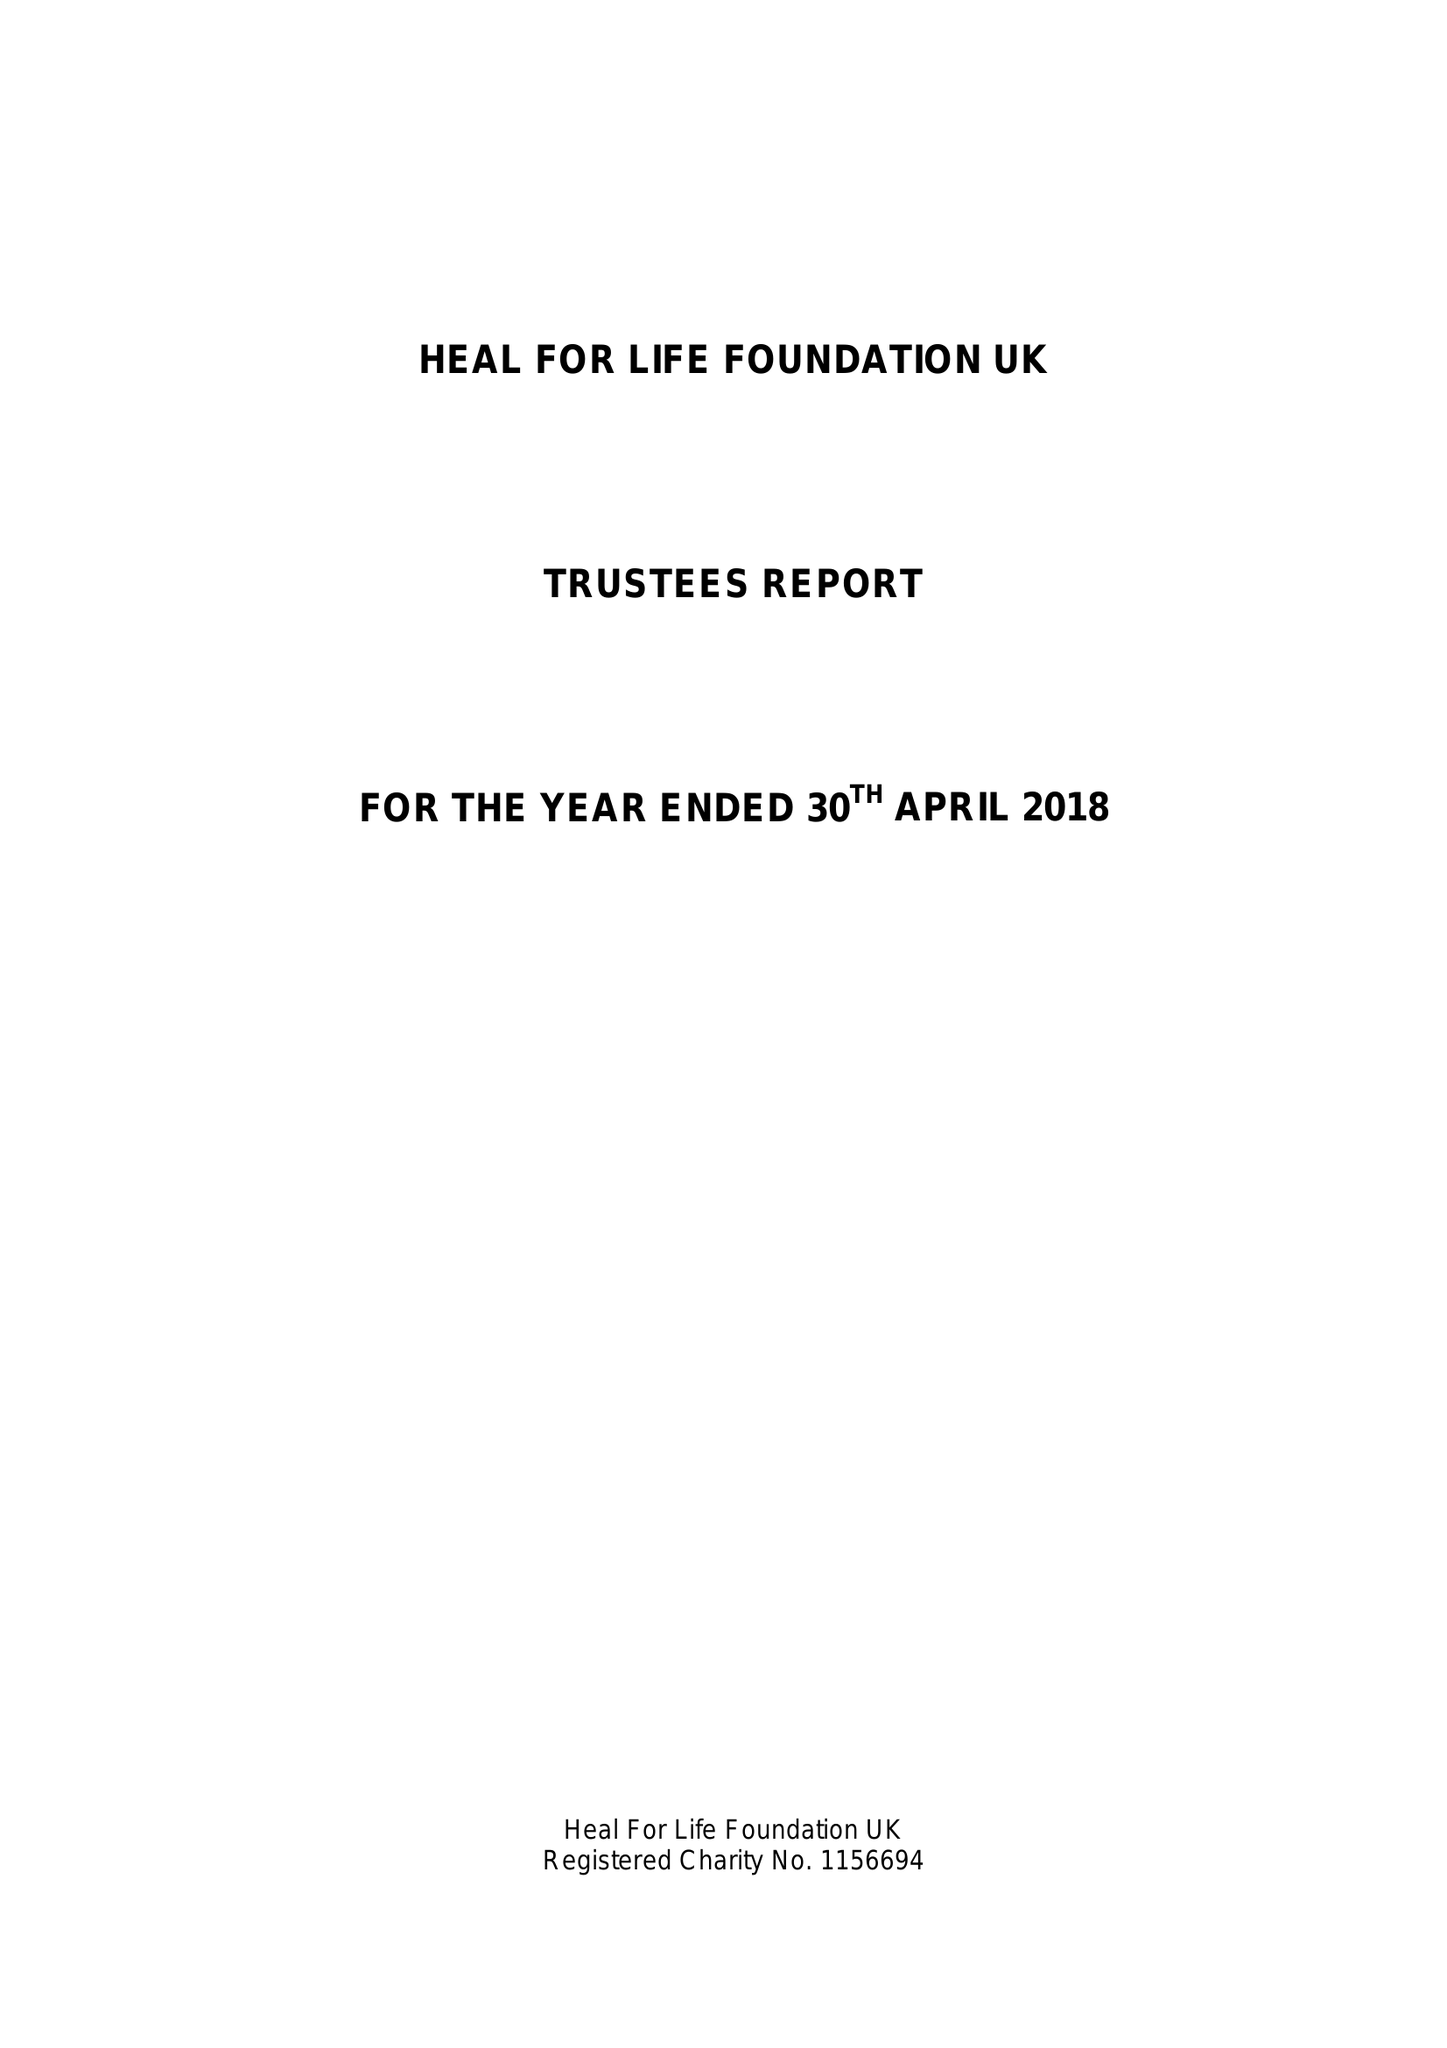What is the value for the spending_annually_in_british_pounds?
Answer the question using a single word or phrase. 12262.83 